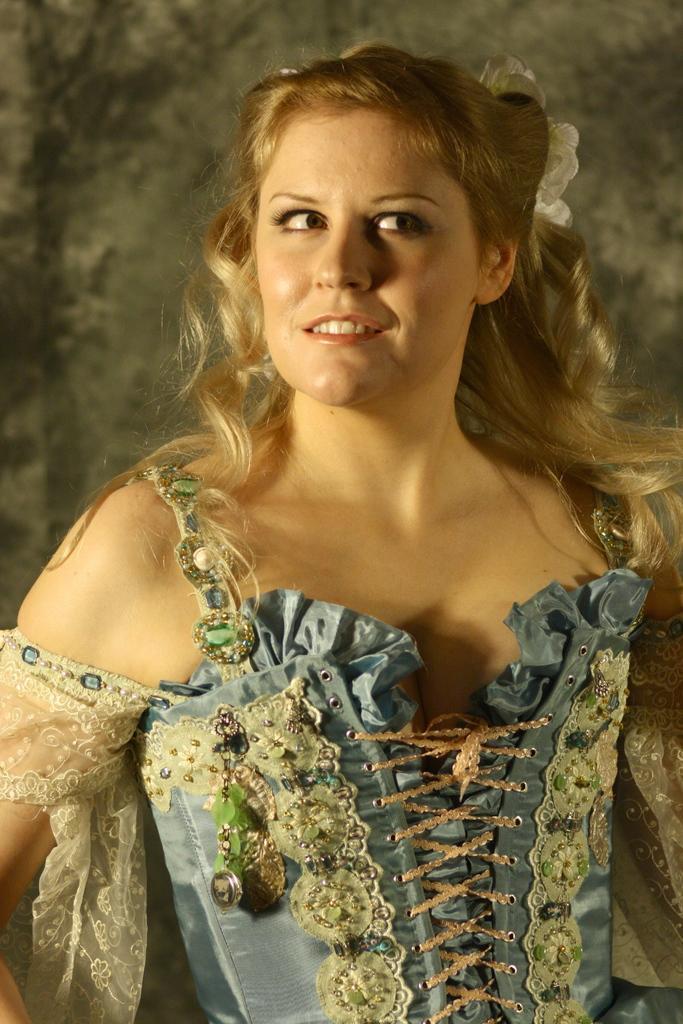Can you describe this image briefly? In the center of the image we can see one woman standing and she is smiling,which we can see on her face. And she is in different costume. In the background there is a wall. 